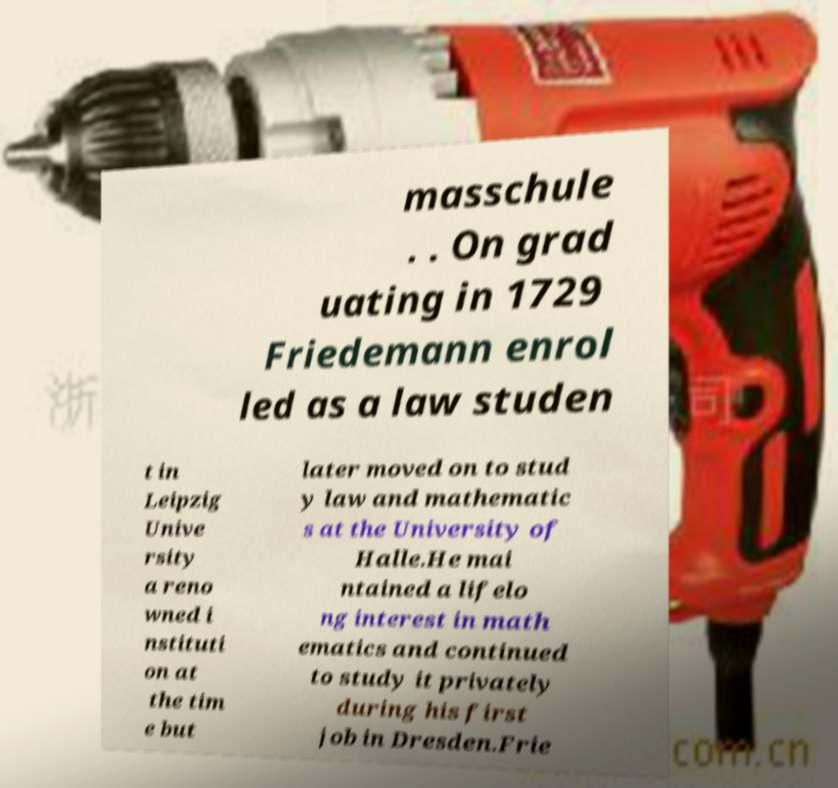For documentation purposes, I need the text within this image transcribed. Could you provide that? masschule . . On grad uating in 1729 Friedemann enrol led as a law studen t in Leipzig Unive rsity a reno wned i nstituti on at the tim e but later moved on to stud y law and mathematic s at the University of Halle.He mai ntained a lifelo ng interest in math ematics and continued to study it privately during his first job in Dresden.Frie 